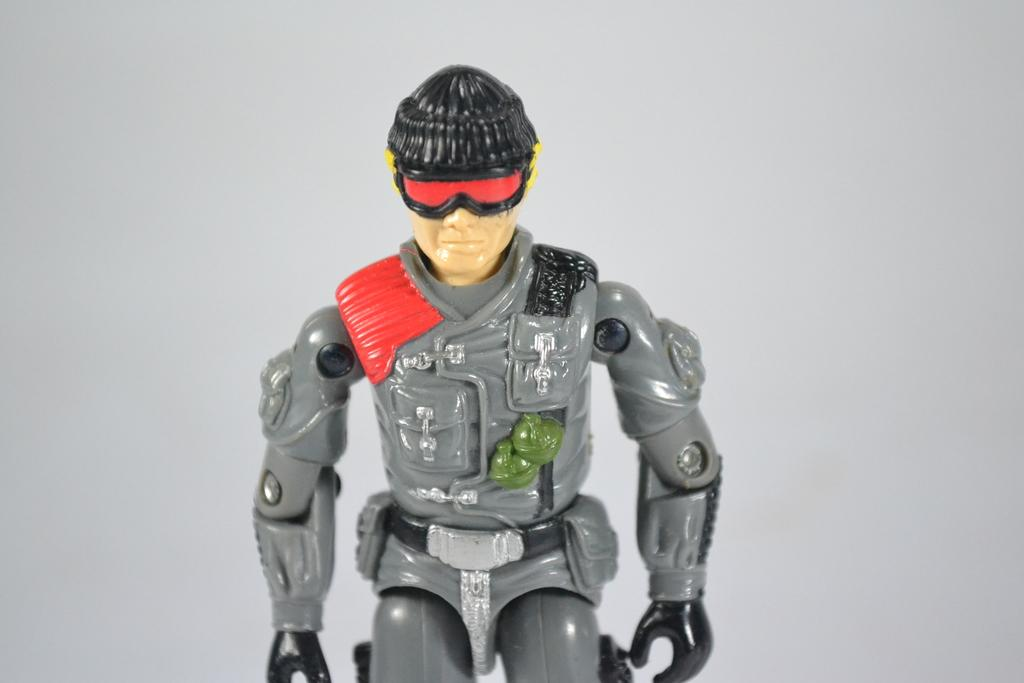What type of object is in the image? There is a toy of a person in the image. What color is the background of the image? The background of the image is gray. What type of dinner is being served in the image? There is no dinner present in the image; it only features a toy of a person against a gray background. 